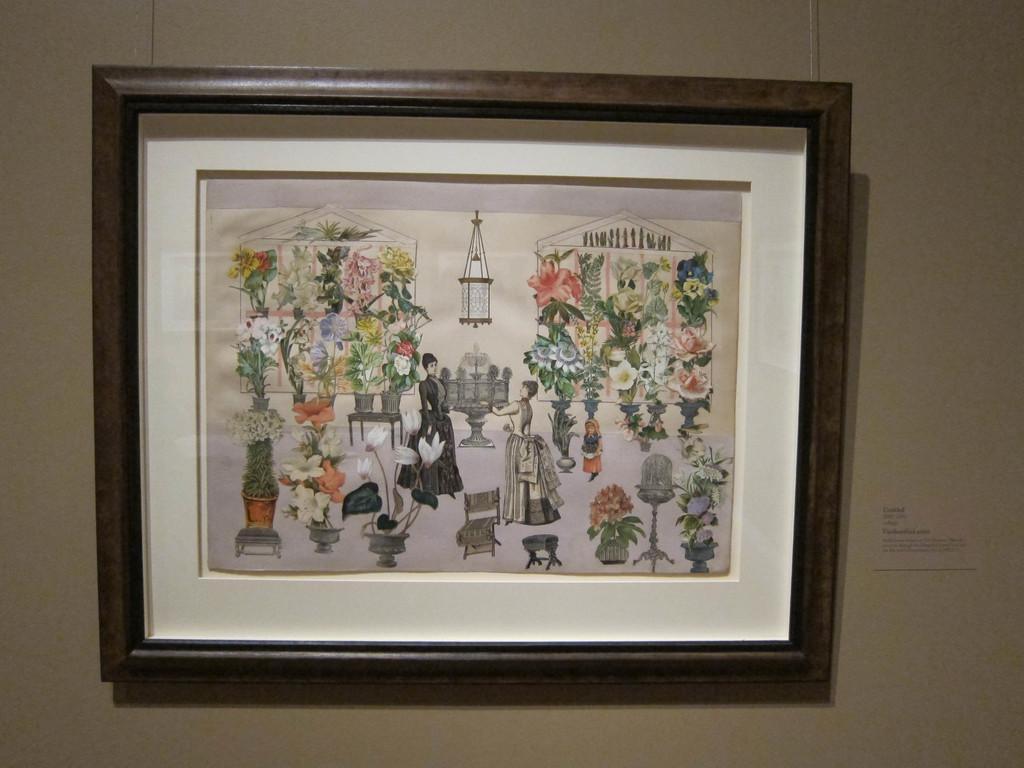Can you describe this image briefly? In this image we can see photo frame on the wall. 